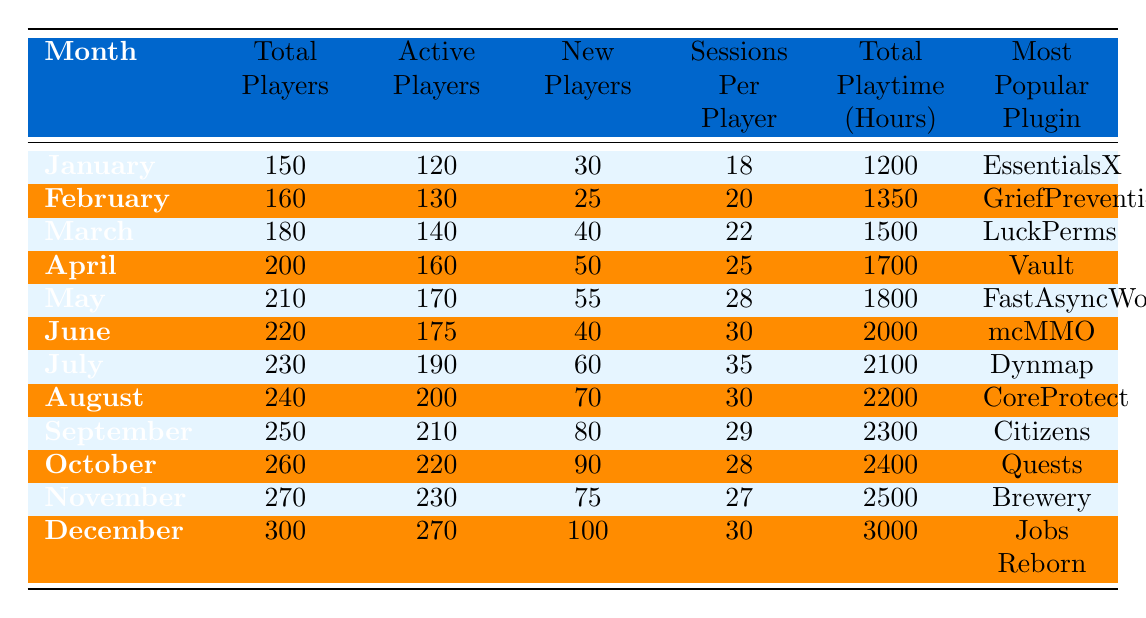What was the most popular plugin in July? From the July row in the table, the most popular plugin listed is Dynmap.
Answer: Dynmap How many new players joined in March? Looking at the March row, it shows that 40 new players joined in that month.
Answer: 40 What is the total playtime in hours for December? The December row indicates a total playtime of 3000 hours.
Answer: 3000 Which month had the highest number of active players? By comparing all active players across the months, December had the highest with 270 active players.
Answer: December What is the percentage increase in total players from January to December? The total players in January are 150 and in December are 300. The increase is (300 - 150) / 150 * 100 = 100%.
Answer: 100% What was the average number of sessions per player from January to June? To find the average, sum the sessions per player from January (18), February (20), March (22), April (25), May (28), June (30) = 143. There are 6 months, so average = 143 / 6 = 23.83.
Answer: 23.83 Did the new players in April exceed those in February? April had 50 new players and February had 25 new players. Since 50 > 25, the statement is true.
Answer: Yes What was the total playtime for the first half of the year (January to June)? The total playtime in hours for the first half of the year is the sum of playtime from January (1200), February (1350), March (1500), April (1700), May (1800), June (2000) = 11550 hours.
Answer: 11550 What month showed the highest increase in new players compared to the previous month? Comparing new players by month, July (60) had an increase from June (40), which is an increase of 20, the highest.
Answer: July Which plugin was the most popular in October? From the October row, the most popular plugin is Quests.
Answer: Quests How many more total players were there in December compared to January? December had 300 total players and January had 150. The difference is 300 - 150 = 150.
Answer: 150 What was the average number of new players per month for the year 2023? The total new players from all months is 30 + 25 + 40 + 50 + 55 + 40 + 60 + 70 + 80 + 90 + 75 + 100 =  520. There are 12 months, so the average is 520 / 12 = 43.33.
Answer: 43.33 What was the change in sessions per player from November to October? In November, sessions per player were 27 and in October they were 28. The change is 27 - 28 = -1, indicating a decrease.
Answer: Decrease Was there a month where total playtime exceeded 2000 hours? Yes, from the data, June (2000), July (2100), August (2200), September (2300), October (2400), November (2500), and December (3000) all exceeded 2000 hours.
Answer: Yes 